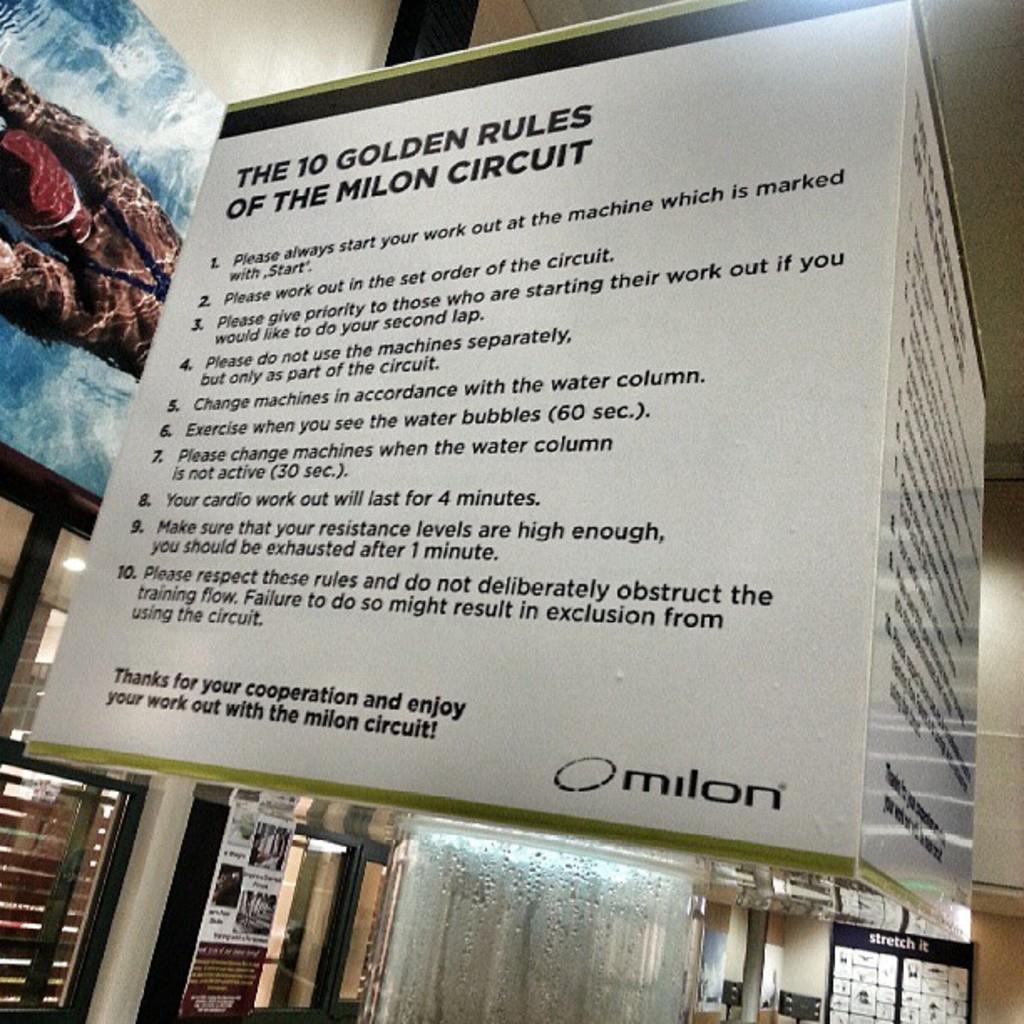Describe this image in one or two sentences. In this picture I can see the board in front, on which there are words written. In the background I can see the walls and I can see the glasses. I can also see 2 boards on the left and right of this picture. 